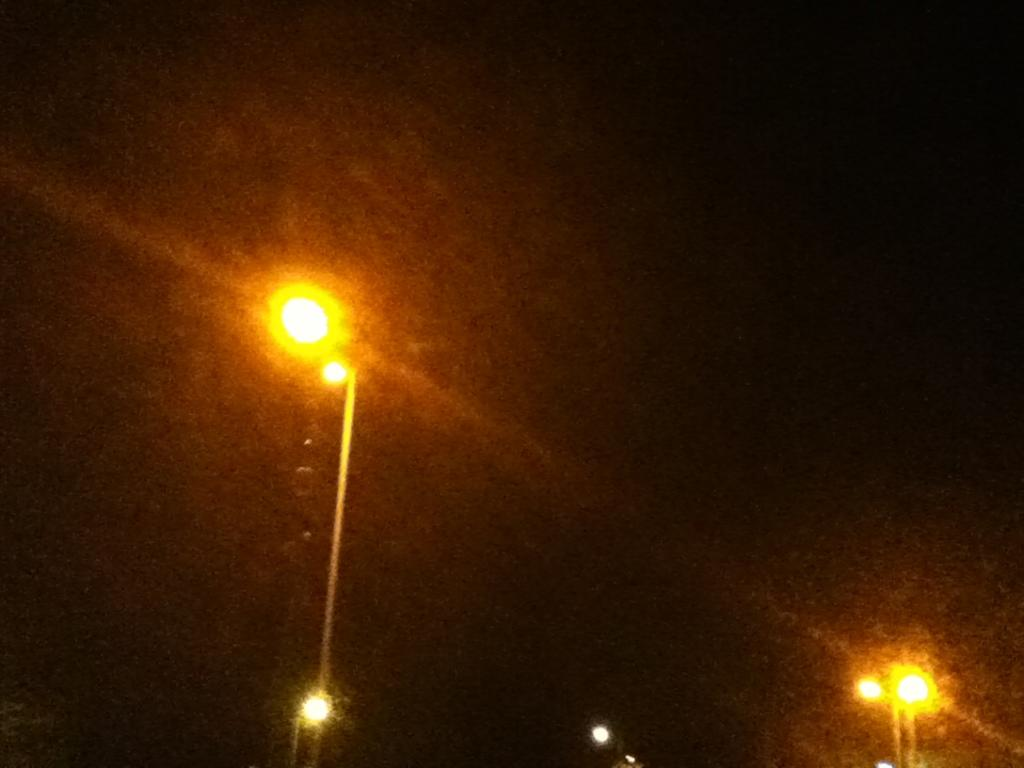What time of day was the image taken? The image was taken during night time. What can be seen in the image that provides light? There are light poles in the image. What color is the background of the image? The background of the image is black. What type of gate can be seen in the image? There is no gate present in the image. How does the coach appear in the image? There is no coach present in the image. 